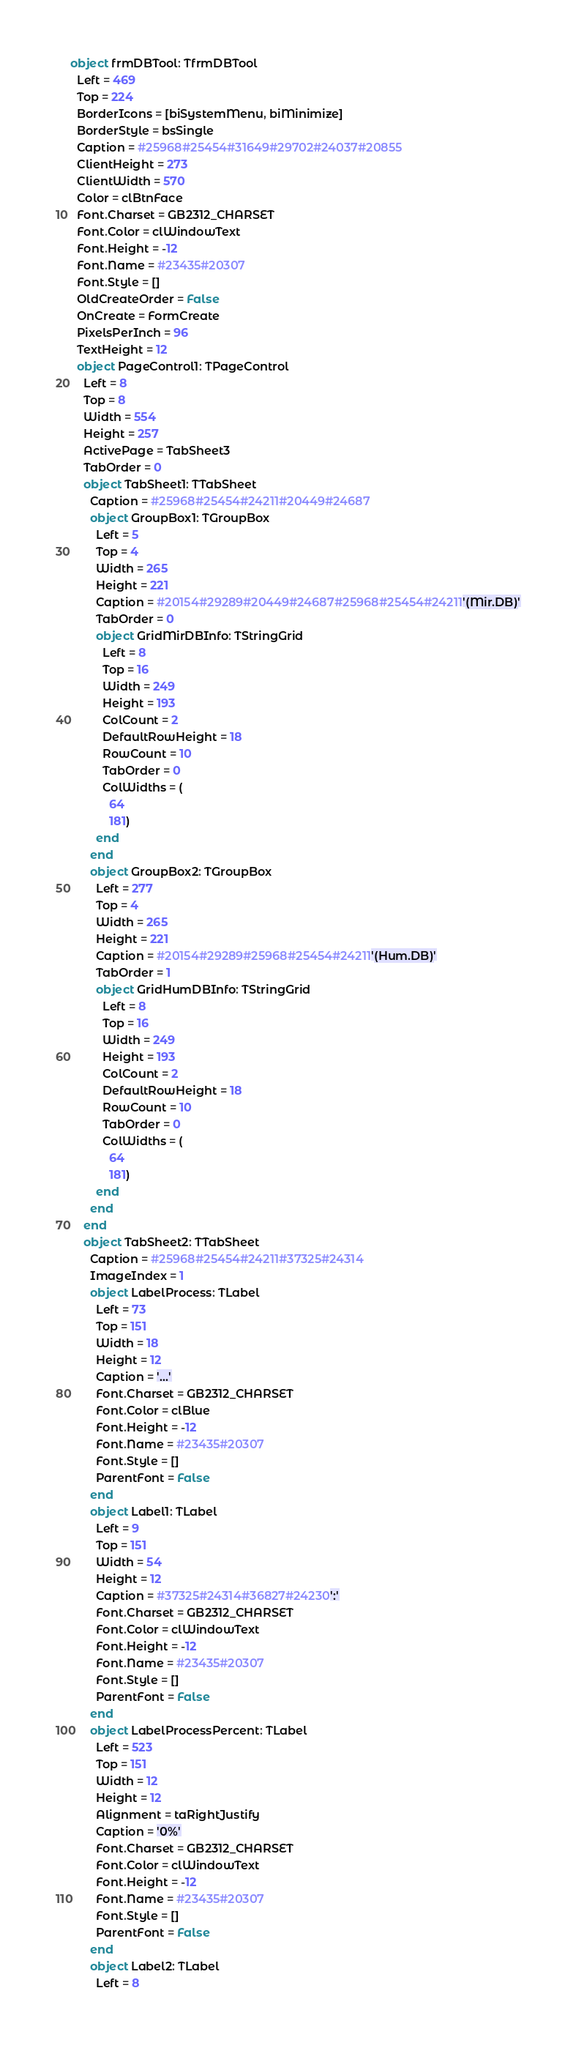Convert code to text. <code><loc_0><loc_0><loc_500><loc_500><_Pascal_>object frmDBTool: TfrmDBTool
  Left = 469
  Top = 224
  BorderIcons = [biSystemMenu, biMinimize]
  BorderStyle = bsSingle
  Caption = #25968#25454#31649#29702#24037#20855
  ClientHeight = 273
  ClientWidth = 570
  Color = clBtnFace
  Font.Charset = GB2312_CHARSET
  Font.Color = clWindowText
  Font.Height = -12
  Font.Name = #23435#20307
  Font.Style = []
  OldCreateOrder = False
  OnCreate = FormCreate
  PixelsPerInch = 96
  TextHeight = 12
  object PageControl1: TPageControl
    Left = 8
    Top = 8
    Width = 554
    Height = 257
    ActivePage = TabSheet3
    TabOrder = 0
    object TabSheet1: TTabSheet
      Caption = #25968#25454#24211#20449#24687
      object GroupBox1: TGroupBox
        Left = 5
        Top = 4
        Width = 265
        Height = 221
        Caption = #20154#29289#20449#24687#25968#25454#24211'(Mir.DB)'
        TabOrder = 0
        object GridMirDBInfo: TStringGrid
          Left = 8
          Top = 16
          Width = 249
          Height = 193
          ColCount = 2
          DefaultRowHeight = 18
          RowCount = 10
          TabOrder = 0
          ColWidths = (
            64
            181)
        end
      end
      object GroupBox2: TGroupBox
        Left = 277
        Top = 4
        Width = 265
        Height = 221
        Caption = #20154#29289#25968#25454#24211'(Hum.DB)'
        TabOrder = 1
        object GridHumDBInfo: TStringGrid
          Left = 8
          Top = 16
          Width = 249
          Height = 193
          ColCount = 2
          DefaultRowHeight = 18
          RowCount = 10
          TabOrder = 0
          ColWidths = (
            64
            181)
        end
      end
    end
    object TabSheet2: TTabSheet
      Caption = #25968#25454#24211#37325#24314
      ImageIndex = 1
      object LabelProcess: TLabel
        Left = 73
        Top = 151
        Width = 18
        Height = 12
        Caption = '...'
        Font.Charset = GB2312_CHARSET
        Font.Color = clBlue
        Font.Height = -12
        Font.Name = #23435#20307
        Font.Style = []
        ParentFont = False
      end
      object Label1: TLabel
        Left = 9
        Top = 151
        Width = 54
        Height = 12
        Caption = #37325#24314#36827#24230':'
        Font.Charset = GB2312_CHARSET
        Font.Color = clWindowText
        Font.Height = -12
        Font.Name = #23435#20307
        Font.Style = []
        ParentFont = False
      end
      object LabelProcessPercent: TLabel
        Left = 523
        Top = 151
        Width = 12
        Height = 12
        Alignment = taRightJustify
        Caption = '0%'
        Font.Charset = GB2312_CHARSET
        Font.Color = clWindowText
        Font.Height = -12
        Font.Name = #23435#20307
        Font.Style = []
        ParentFont = False
      end
      object Label2: TLabel
        Left = 8</code> 